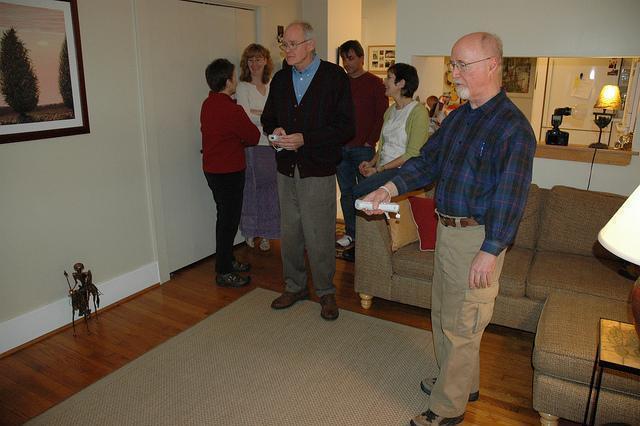Where have these people gathered?
Indicate the correct response by choosing from the four available options to answer the question.
Options: Library, home, reception hall, church. Home. 